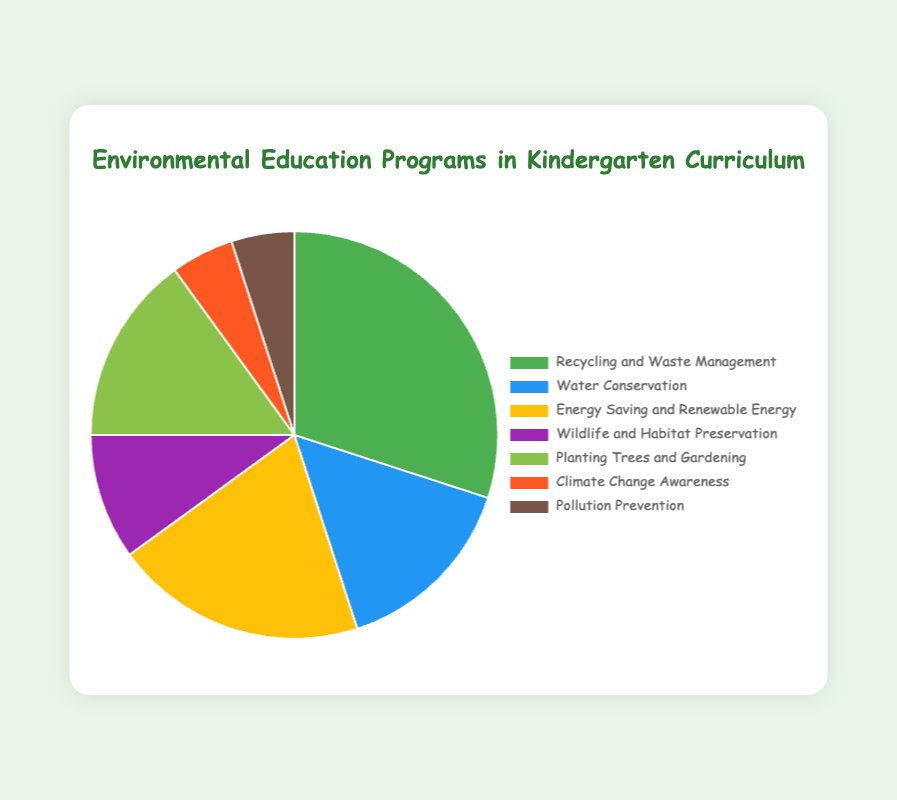Which program takes up the largest portion of the curriculum? By looking at the pie chart, we can see that the 'Recycling and Waste Management' section is the largest.
Answer: Recycling and Waste Management How does the allocation for 'Planting Trees and Gardening' compare to 'Water Conservation'? Comparing the two slices, both 'Planting Trees and Gardening' and 'Water Conservation' take up 15% each, making them equal in size.
Answer: Equal What is the combined percentage of 'Climate Change Awareness' and 'Pollution Prevention'? 'Climate Change Awareness' is 5% and 'Pollution Prevention' is also 5%. Adding them together gives 5% + 5% = 10%.
Answer: 10% What is the difference between the largest and smallest allocations? The largest allocation is 'Recycling and Waste Management' at 30% and the smallest allocations are 'Climate Change Awareness' and 'Pollution Prevention' at 5% each. The difference is 30% - 5% = 25%.
Answer: 25% What percentage of the curriculum is dedicated to wildlife and habitat preservation and planting trees and gardening combined? 'Wildlife and Habitat Preservation' is 10% and 'Planting Trees and Gardening' is 15%. Adding these together gives 10% + 15% = 25%.
Answer: 25% Which program is represented by the yellow slice? The yellow slice on the pie chart corresponds to 'Energy Saving and Renewable Energy'.
Answer: Energy Saving and Renewable Energy Is the portion for 'Energy Saving and Renewable Energy' greater than 'Water Conservation'? The portion for 'Energy Saving and Renewable Energy' is 20% and for 'Water Conservation' is 15%. 20% is greater than 15%.
Answer: Yes How many programs have an allocation of 15%? The chart shows that 'Water Conservation' and 'Planting Trees and Gardening' each have an allocation of 15%. That makes 2 programs in total.
Answer: 2 What percentage of the curriculum is allocated to programs other than 'Recycling and Waste Management'? 'Recycling and Waste Management' is 30%. Subtracting that from 100% gives 100% - 30% = 70%.
Answer: 70% What is the average allocation percentage for all programs? Summing up all allocations gives 30% + 15% + 20% + 10% + 15% + 5% + 5% = 100%. There are 7 programs in total. The average is 100% / 7 ≈ 14.29%.
Answer: 14.29% 